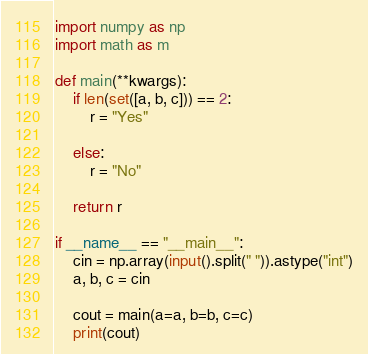<code> <loc_0><loc_0><loc_500><loc_500><_Python_>import numpy as np
import math as m

def main(**kwargs):
    if len(set([a, b, c])) == 2:
        r = "Yes"

    else:
        r = "No"

    return r

if __name__ == "__main__":
    cin = np.array(input().split(" ")).astype("int")
    a, b, c = cin

    cout = main(a=a, b=b, c=c)
    print(cout)</code> 